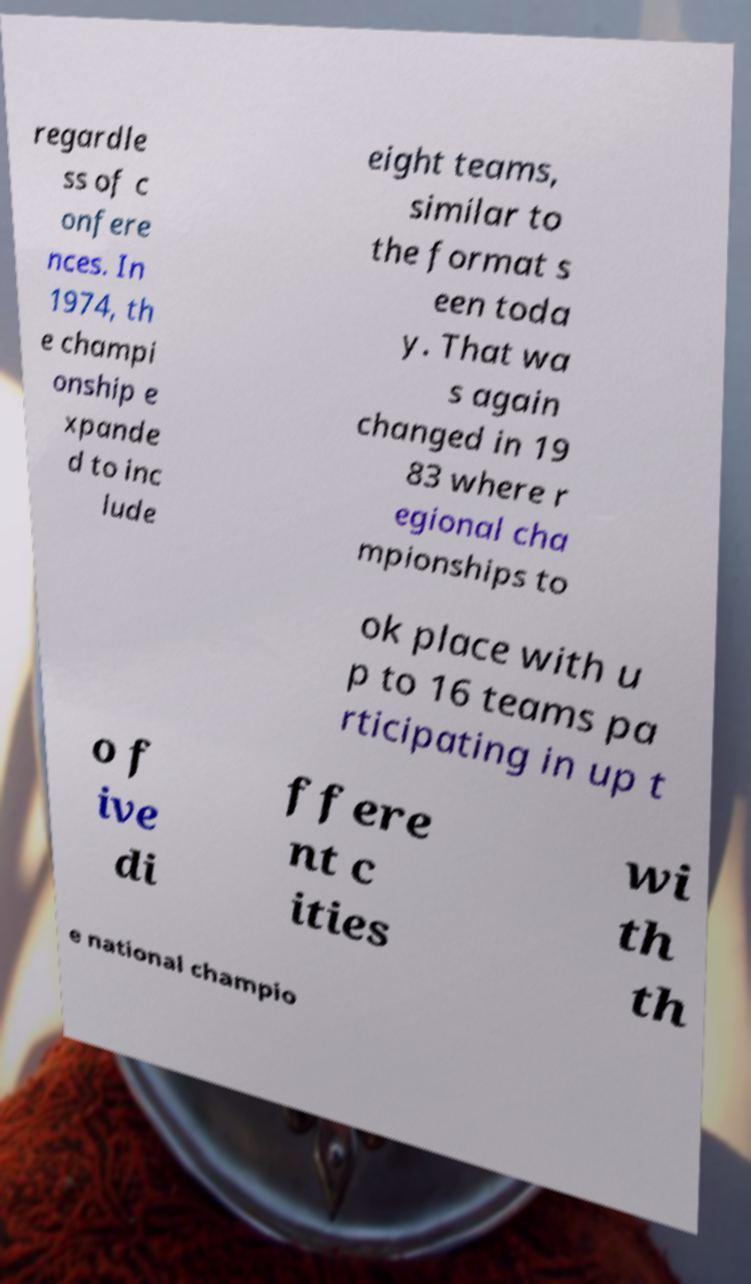Please identify and transcribe the text found in this image. regardle ss of c onfere nces. In 1974, th e champi onship e xpande d to inc lude eight teams, similar to the format s een toda y. That wa s again changed in 19 83 where r egional cha mpionships to ok place with u p to 16 teams pa rticipating in up t o f ive di ffere nt c ities wi th th e national champio 